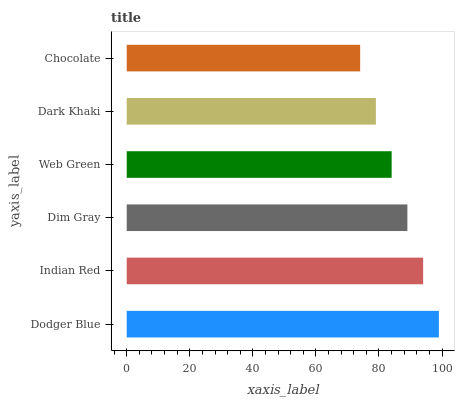Is Chocolate the minimum?
Answer yes or no. Yes. Is Dodger Blue the maximum?
Answer yes or no. Yes. Is Indian Red the minimum?
Answer yes or no. No. Is Indian Red the maximum?
Answer yes or no. No. Is Dodger Blue greater than Indian Red?
Answer yes or no. Yes. Is Indian Red less than Dodger Blue?
Answer yes or no. Yes. Is Indian Red greater than Dodger Blue?
Answer yes or no. No. Is Dodger Blue less than Indian Red?
Answer yes or no. No. Is Dim Gray the high median?
Answer yes or no. Yes. Is Web Green the low median?
Answer yes or no. Yes. Is Chocolate the high median?
Answer yes or no. No. Is Dodger Blue the low median?
Answer yes or no. No. 